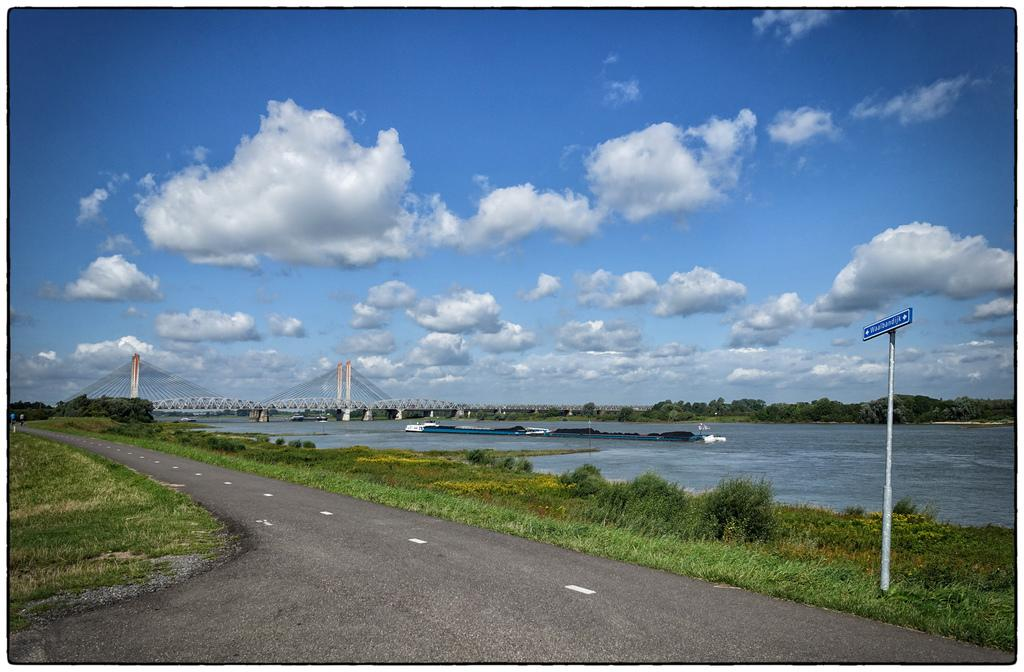What is the main feature of the image? There is a road in the image. What can be seen on either side of the road? Grass is present on either side of the road. What is located on the right side of the image? A river, a bridge, a sign board, and trees are visible on the right side of the image. What is the color of the sky in the image? The sky is blue in the image. How many locks are visible on the bridge in the image? There are no locks visible on the bridge in the image. What type of grip does the river have on the trees in the image? There is no mention of the river having a grip on the trees in the image. 